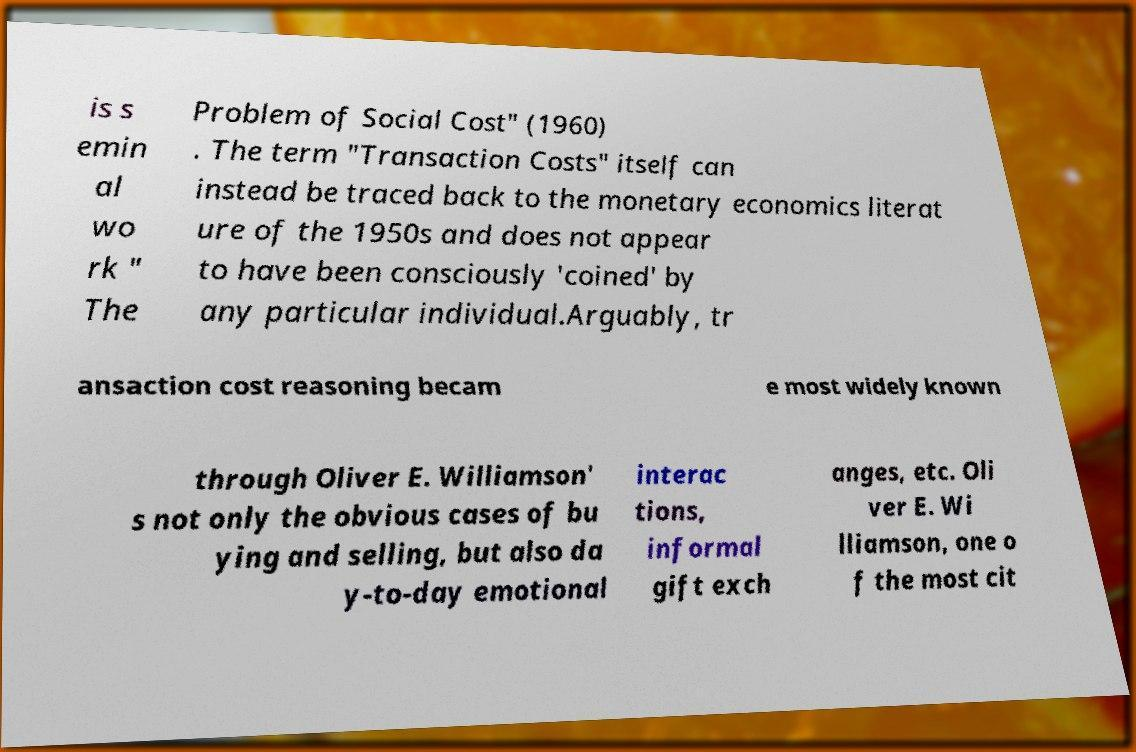Could you assist in decoding the text presented in this image and type it out clearly? is s emin al wo rk " The Problem of Social Cost" (1960) . The term "Transaction Costs" itself can instead be traced back to the monetary economics literat ure of the 1950s and does not appear to have been consciously 'coined' by any particular individual.Arguably, tr ansaction cost reasoning becam e most widely known through Oliver E. Williamson' s not only the obvious cases of bu ying and selling, but also da y-to-day emotional interac tions, informal gift exch anges, etc. Oli ver E. Wi lliamson, one o f the most cit 